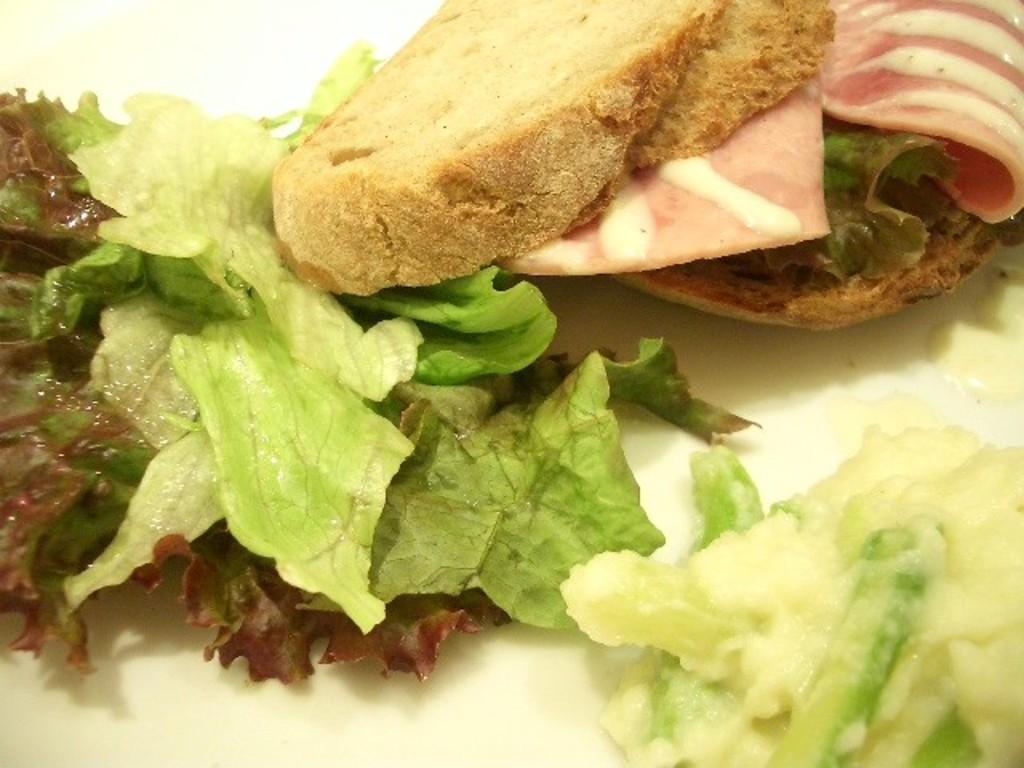What can be seen in the image? There are food items in the image. What is the food placed on? The food items are on an object. Can you tell me how many houses are visible in the image? There are no houses visible in the image; it only contains food items and an object. What type of pencil can be seen being used to draw in the image? There is no pencil present in the image. 